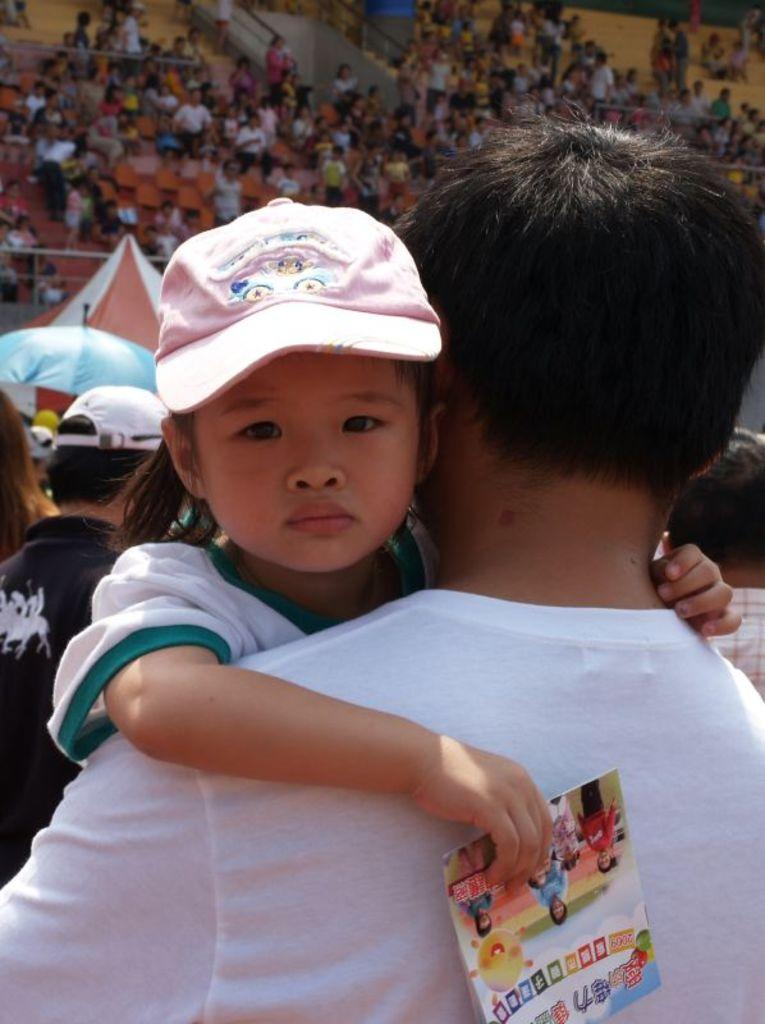What is the main subject of the image? The main subject of the image is a small kid. Can you describe the kid's appearance? The kid is wearing a pink cap. Who else is present in the image? There is a man in the image. What is the man wearing? The man is wearing a white T-shirt. What can be seen in the background of the image? There are many people in the background of the image. What type of location might the image be taken in? The image appears to be taken in a stadium. What type of plantation can be seen in the background of the image? There is no plantation present in the image; it appears to be taken in a stadium. Who is the father of the small kid in the image? The provided facts do not mention the relationship between the small kid and the man in the image, so we cannot determine if the man is the kid's father. 